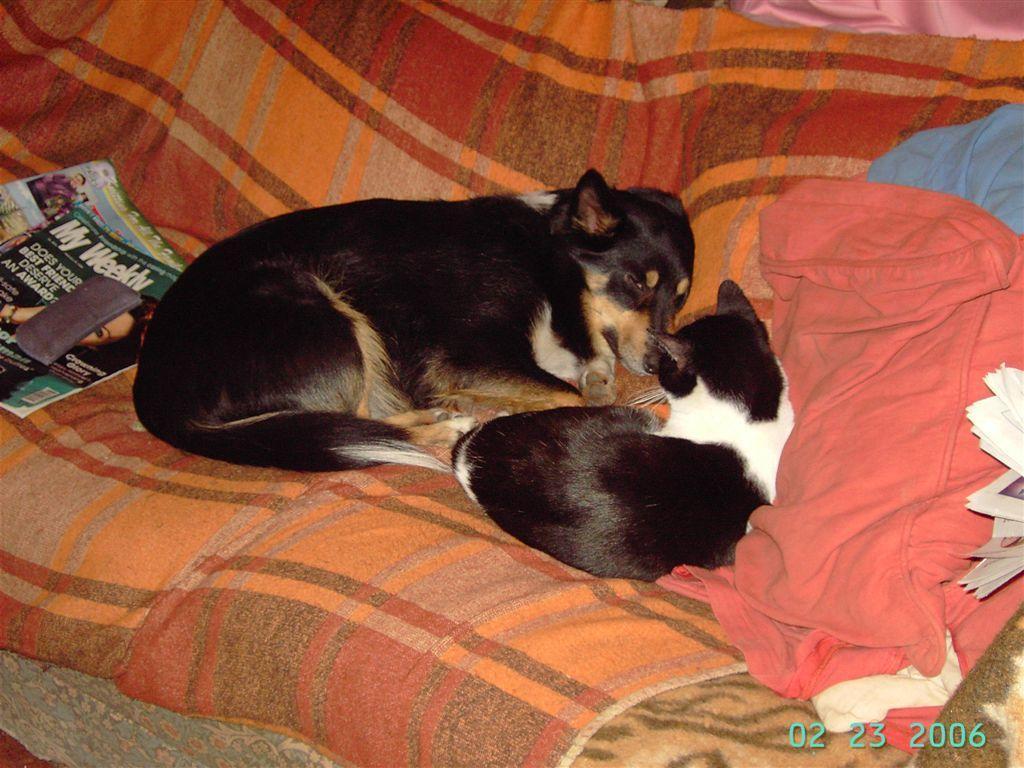How would you summarize this image in a sentence or two? In this image, we can see a cat and dog is lying on a cloth. On the left side, we can see books and object. On the right side of the image, we can see cushions, few papers, cloth and watermark. This watermark represents date. 